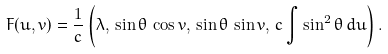Convert formula to latex. <formula><loc_0><loc_0><loc_500><loc_500>F ( u , v ) = \frac { 1 } { c } \left ( \lambda , \, \sin \theta \, \cos v , \, \sin \theta \, \sin v , \, c \int \sin ^ { 2 } \theta \, d u \right ) .</formula> 